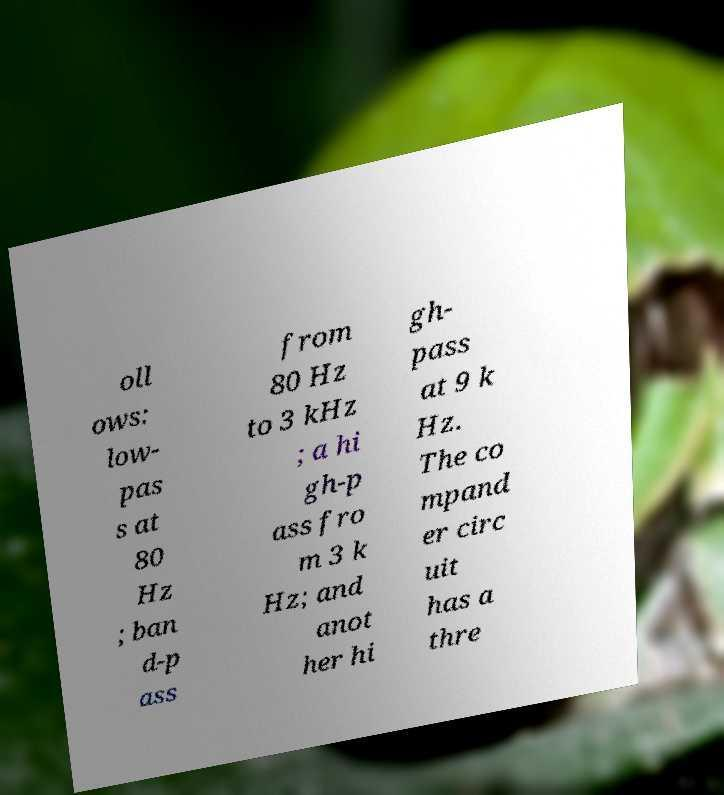What messages or text are displayed in this image? I need them in a readable, typed format. oll ows: low- pas s at 80 Hz ; ban d-p ass from 80 Hz to 3 kHz ; a hi gh-p ass fro m 3 k Hz; and anot her hi gh- pass at 9 k Hz. The co mpand er circ uit has a thre 